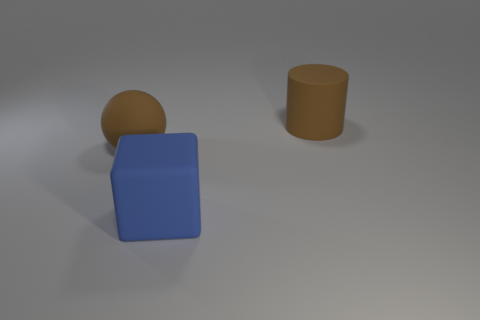If this image were part of a children's educational book, what might the accompanying text say? The accompanying text might say: 'Explore the world of shapes and colors! Here we have a large, blue cube, a brown sphere, and a brown cylinder. Notice how each shape is different - some have edges, while others are perfectly round.' 